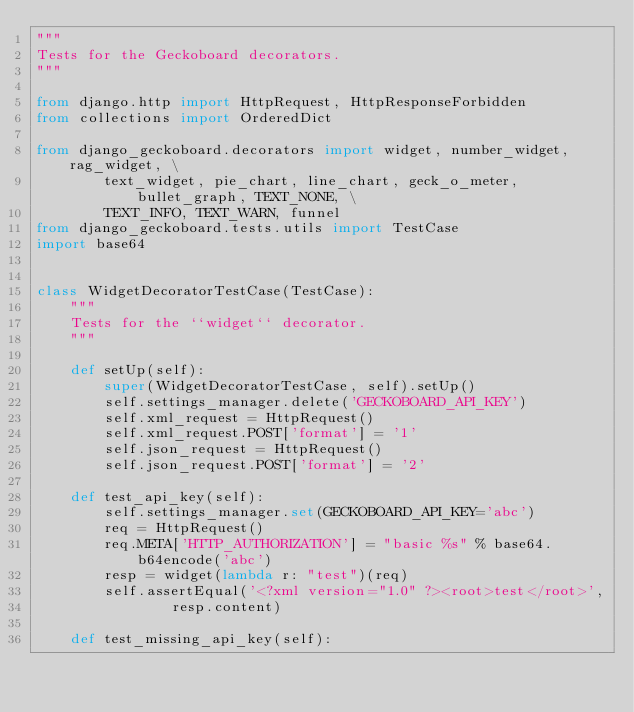Convert code to text. <code><loc_0><loc_0><loc_500><loc_500><_Python_>"""
Tests for the Geckoboard decorators.
"""

from django.http import HttpRequest, HttpResponseForbidden
from collections import OrderedDict 

from django_geckoboard.decorators import widget, number_widget, rag_widget, \
        text_widget, pie_chart, line_chart, geck_o_meter, bullet_graph, TEXT_NONE, \
        TEXT_INFO, TEXT_WARN, funnel
from django_geckoboard.tests.utils import TestCase
import base64


class WidgetDecoratorTestCase(TestCase):
    """
    Tests for the ``widget`` decorator.
    """

    def setUp(self):
        super(WidgetDecoratorTestCase, self).setUp()
        self.settings_manager.delete('GECKOBOARD_API_KEY')
        self.xml_request = HttpRequest()
        self.xml_request.POST['format'] = '1'
        self.json_request = HttpRequest()
        self.json_request.POST['format'] = '2'

    def test_api_key(self):
        self.settings_manager.set(GECKOBOARD_API_KEY='abc')
        req = HttpRequest()
        req.META['HTTP_AUTHORIZATION'] = "basic %s" % base64.b64encode('abc')
        resp = widget(lambda r: "test")(req)
        self.assertEqual('<?xml version="1.0" ?><root>test</root>',
                resp.content)

    def test_missing_api_key(self):</code> 